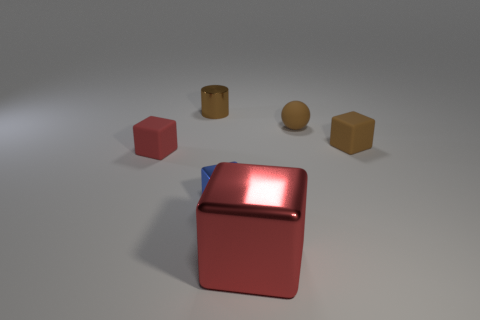What number of tiny metallic cylinders have the same color as the small sphere?
Provide a succinct answer. 1. How many tiny cyan spheres are the same material as the big red object?
Offer a very short reply. 0. There is a red cube to the right of the metal thing behind the tiny brown rubber cube; are there any small cylinders behind it?
Your answer should be very brief. Yes. What shape is the brown thing that is the same material as the big red block?
Ensure brevity in your answer.  Cylinder. Are there more brown rubber blocks than big purple metal cylinders?
Your answer should be compact. Yes. Is the shape of the small red matte thing the same as the object that is in front of the blue metal cube?
Ensure brevity in your answer.  Yes. What is the material of the brown sphere?
Ensure brevity in your answer.  Rubber. There is a tiny shiny thing that is in front of the matte object that is on the left side of the brown thing left of the brown ball; what color is it?
Provide a short and direct response. Blue. There is a brown thing that is the same shape as the small blue metallic thing; what material is it?
Offer a very short reply. Rubber. How many other metallic objects have the same size as the brown shiny thing?
Ensure brevity in your answer.  1. 